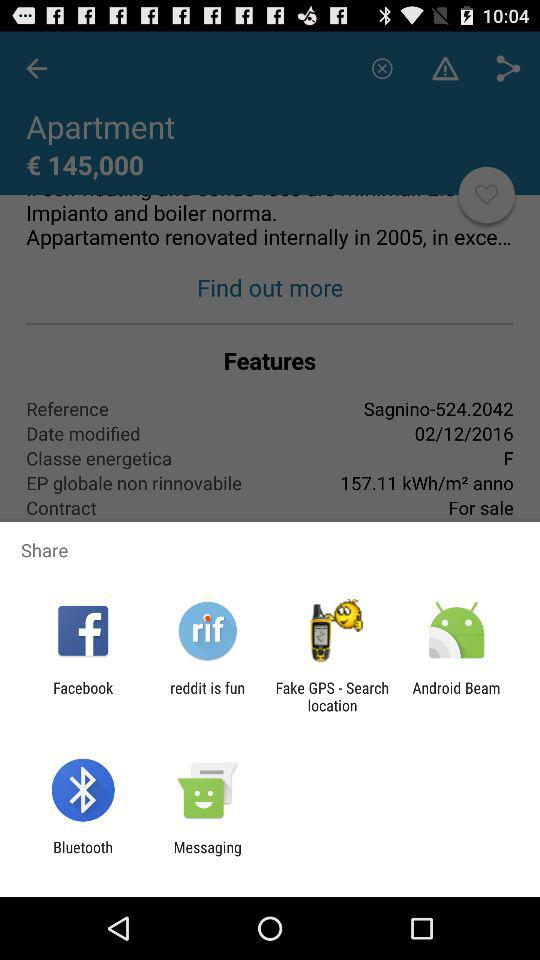What are the sharing options available? The sharing options are "Facebook", "reddit is fun", "Fake GPS - Search location", "Android Beam", "Bluetooth", and "Messaging". 